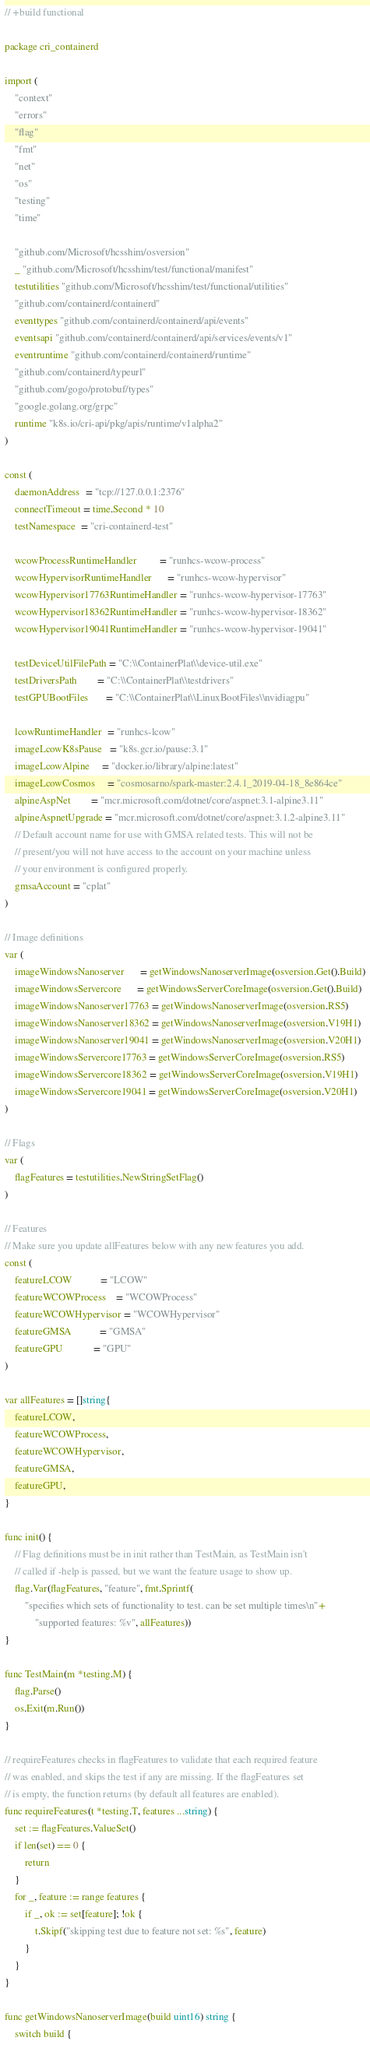Convert code to text. <code><loc_0><loc_0><loc_500><loc_500><_Go_>// +build functional

package cri_containerd

import (
	"context"
	"errors"
	"flag"
	"fmt"
	"net"
	"os"
	"testing"
	"time"

	"github.com/Microsoft/hcsshim/osversion"
	_ "github.com/Microsoft/hcsshim/test/functional/manifest"
	testutilities "github.com/Microsoft/hcsshim/test/functional/utilities"
	"github.com/containerd/containerd"
	eventtypes "github.com/containerd/containerd/api/events"
	eventsapi "github.com/containerd/containerd/api/services/events/v1"
	eventruntime "github.com/containerd/containerd/runtime"
	"github.com/containerd/typeurl"
	"github.com/gogo/protobuf/types"
	"google.golang.org/grpc"
	runtime "k8s.io/cri-api/pkg/apis/runtime/v1alpha2"
)

const (
	daemonAddress  = "tcp://127.0.0.1:2376"
	connectTimeout = time.Second * 10
	testNamespace  = "cri-containerd-test"

	wcowProcessRuntimeHandler         = "runhcs-wcow-process"
	wcowHypervisorRuntimeHandler      = "runhcs-wcow-hypervisor"
	wcowHypervisor17763RuntimeHandler = "runhcs-wcow-hypervisor-17763"
	wcowHypervisor18362RuntimeHandler = "runhcs-wcow-hypervisor-18362"
	wcowHypervisor19041RuntimeHandler = "runhcs-wcow-hypervisor-19041"

	testDeviceUtilFilePath = "C:\\ContainerPlat\\device-util.exe"
	testDriversPath        = "C:\\ContainerPlat\\testdrivers"
	testGPUBootFiles       = "C:\\ContainerPlat\\LinuxBootFiles\\nvidiagpu"

	lcowRuntimeHandler  = "runhcs-lcow"
	imageLcowK8sPause   = "k8s.gcr.io/pause:3.1"
	imageLcowAlpine     = "docker.io/library/alpine:latest"
	imageLcowCosmos     = "cosmosarno/spark-master:2.4.1_2019-04-18_8e864ce"
	alpineAspNet        = "mcr.microsoft.com/dotnet/core/aspnet:3.1-alpine3.11"
	alpineAspnetUpgrade = "mcr.microsoft.com/dotnet/core/aspnet:3.1.2-alpine3.11"
	// Default account name for use with GMSA related tests. This will not be
	// present/you will not have access to the account on your machine unless
	// your environment is configured properly.
	gmsaAccount = "cplat"
)

// Image definitions
var (
	imageWindowsNanoserver      = getWindowsNanoserverImage(osversion.Get().Build)
	imageWindowsServercore      = getWindowsServerCoreImage(osversion.Get().Build)
	imageWindowsNanoserver17763 = getWindowsNanoserverImage(osversion.RS5)
	imageWindowsNanoserver18362 = getWindowsNanoserverImage(osversion.V19H1)
	imageWindowsNanoserver19041 = getWindowsNanoserverImage(osversion.V20H1)
	imageWindowsServercore17763 = getWindowsServerCoreImage(osversion.RS5)
	imageWindowsServercore18362 = getWindowsServerCoreImage(osversion.V19H1)
	imageWindowsServercore19041 = getWindowsServerCoreImage(osversion.V20H1)
)

// Flags
var (
	flagFeatures = testutilities.NewStringSetFlag()
)

// Features
// Make sure you update allFeatures below with any new features you add.
const (
	featureLCOW           = "LCOW"
	featureWCOWProcess    = "WCOWProcess"
	featureWCOWHypervisor = "WCOWHypervisor"
	featureGMSA           = "GMSA"
	featureGPU            = "GPU"
)

var allFeatures = []string{
	featureLCOW,
	featureWCOWProcess,
	featureWCOWHypervisor,
	featureGMSA,
	featureGPU,
}

func init() {
	// Flag definitions must be in init rather than TestMain, as TestMain isn't
	// called if -help is passed, but we want the feature usage to show up.
	flag.Var(flagFeatures, "feature", fmt.Sprintf(
		"specifies which sets of functionality to test. can be set multiple times\n"+
			"supported features: %v", allFeatures))
}

func TestMain(m *testing.M) {
	flag.Parse()
	os.Exit(m.Run())
}

// requireFeatures checks in flagFeatures to validate that each required feature
// was enabled, and skips the test if any are missing. If the flagFeatures set
// is empty, the function returns (by default all features are enabled).
func requireFeatures(t *testing.T, features ...string) {
	set := flagFeatures.ValueSet()
	if len(set) == 0 {
		return
	}
	for _, feature := range features {
		if _, ok := set[feature]; !ok {
			t.Skipf("skipping test due to feature not set: %s", feature)
		}
	}
}

func getWindowsNanoserverImage(build uint16) string {
	switch build {</code> 